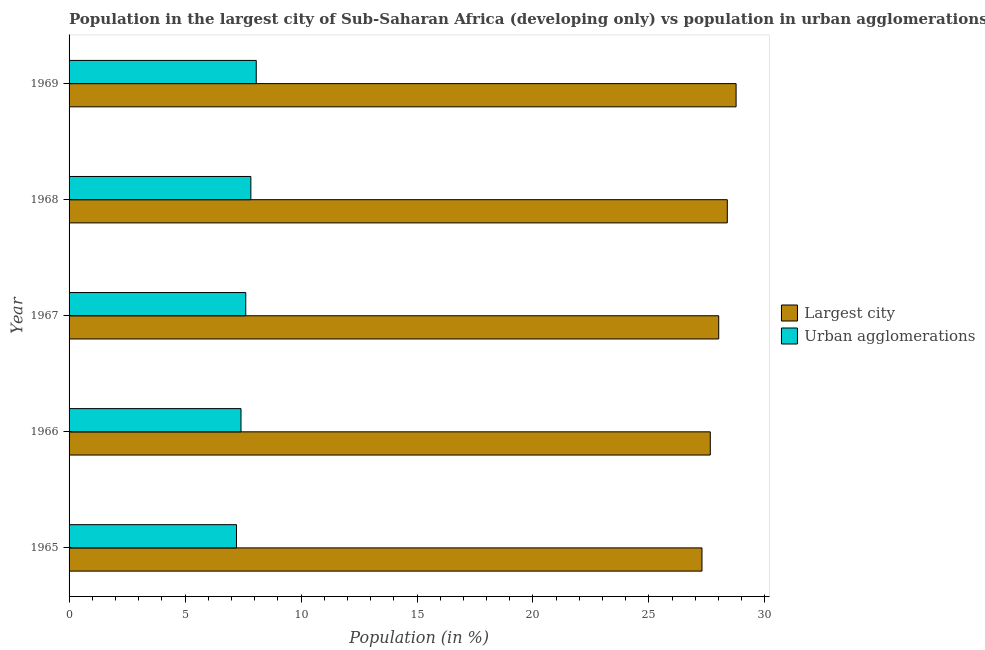How many different coloured bars are there?
Keep it short and to the point. 2. Are the number of bars per tick equal to the number of legend labels?
Provide a short and direct response. Yes. Are the number of bars on each tick of the Y-axis equal?
Your answer should be compact. Yes. What is the label of the 1st group of bars from the top?
Keep it short and to the point. 1969. What is the population in urban agglomerations in 1969?
Your answer should be compact. 8.07. Across all years, what is the maximum population in urban agglomerations?
Ensure brevity in your answer.  8.07. Across all years, what is the minimum population in urban agglomerations?
Ensure brevity in your answer.  7.22. In which year was the population in the largest city maximum?
Your answer should be very brief. 1969. In which year was the population in urban agglomerations minimum?
Give a very brief answer. 1965. What is the total population in urban agglomerations in the graph?
Provide a succinct answer. 38.16. What is the difference between the population in the largest city in 1967 and that in 1968?
Your answer should be compact. -0.37. What is the difference between the population in the largest city in 1967 and the population in urban agglomerations in 1969?
Offer a terse response. 19.94. What is the average population in urban agglomerations per year?
Provide a succinct answer. 7.63. In the year 1969, what is the difference between the population in the largest city and population in urban agglomerations?
Provide a succinct answer. 20.69. In how many years, is the population in urban agglomerations greater than 16 %?
Your answer should be compact. 0. What is the ratio of the population in urban agglomerations in 1968 to that in 1969?
Provide a short and direct response. 0.97. Is the difference between the population in urban agglomerations in 1966 and 1968 greater than the difference between the population in the largest city in 1966 and 1968?
Provide a succinct answer. Yes. What is the difference between the highest and the second highest population in the largest city?
Give a very brief answer. 0.38. What is the difference between the highest and the lowest population in urban agglomerations?
Offer a very short reply. 0.85. What does the 2nd bar from the top in 1965 represents?
Ensure brevity in your answer.  Largest city. What does the 1st bar from the bottom in 1967 represents?
Provide a short and direct response. Largest city. How many years are there in the graph?
Provide a short and direct response. 5. Where does the legend appear in the graph?
Your answer should be compact. Center right. How many legend labels are there?
Your answer should be very brief. 2. How are the legend labels stacked?
Ensure brevity in your answer.  Vertical. What is the title of the graph?
Keep it short and to the point. Population in the largest city of Sub-Saharan Africa (developing only) vs population in urban agglomerations. What is the label or title of the X-axis?
Provide a succinct answer. Population (in %). What is the Population (in %) of Largest city in 1965?
Provide a short and direct response. 27.29. What is the Population (in %) in Urban agglomerations in 1965?
Give a very brief answer. 7.22. What is the Population (in %) in Largest city in 1966?
Offer a very short reply. 27.64. What is the Population (in %) of Urban agglomerations in 1966?
Your answer should be compact. 7.41. What is the Population (in %) of Largest city in 1967?
Offer a very short reply. 28.01. What is the Population (in %) in Urban agglomerations in 1967?
Keep it short and to the point. 7.62. What is the Population (in %) of Largest city in 1968?
Provide a short and direct response. 28.38. What is the Population (in %) of Urban agglomerations in 1968?
Offer a terse response. 7.84. What is the Population (in %) of Largest city in 1969?
Provide a succinct answer. 28.76. What is the Population (in %) of Urban agglomerations in 1969?
Ensure brevity in your answer.  8.07. Across all years, what is the maximum Population (in %) in Largest city?
Make the answer very short. 28.76. Across all years, what is the maximum Population (in %) in Urban agglomerations?
Your answer should be very brief. 8.07. Across all years, what is the minimum Population (in %) of Largest city?
Your answer should be very brief. 27.29. Across all years, what is the minimum Population (in %) of Urban agglomerations?
Keep it short and to the point. 7.22. What is the total Population (in %) in Largest city in the graph?
Give a very brief answer. 140.07. What is the total Population (in %) of Urban agglomerations in the graph?
Your answer should be compact. 38.16. What is the difference between the Population (in %) in Largest city in 1965 and that in 1966?
Provide a succinct answer. -0.36. What is the difference between the Population (in %) in Urban agglomerations in 1965 and that in 1966?
Offer a terse response. -0.19. What is the difference between the Population (in %) in Largest city in 1965 and that in 1967?
Offer a very short reply. -0.72. What is the difference between the Population (in %) of Urban agglomerations in 1965 and that in 1967?
Give a very brief answer. -0.4. What is the difference between the Population (in %) of Largest city in 1965 and that in 1968?
Make the answer very short. -1.09. What is the difference between the Population (in %) in Urban agglomerations in 1965 and that in 1968?
Ensure brevity in your answer.  -0.62. What is the difference between the Population (in %) in Largest city in 1965 and that in 1969?
Offer a terse response. -1.47. What is the difference between the Population (in %) in Urban agglomerations in 1965 and that in 1969?
Keep it short and to the point. -0.85. What is the difference between the Population (in %) in Largest city in 1966 and that in 1967?
Your response must be concise. -0.36. What is the difference between the Population (in %) of Urban agglomerations in 1966 and that in 1967?
Provide a succinct answer. -0.21. What is the difference between the Population (in %) of Largest city in 1966 and that in 1968?
Your answer should be compact. -0.73. What is the difference between the Population (in %) of Urban agglomerations in 1966 and that in 1968?
Offer a terse response. -0.43. What is the difference between the Population (in %) in Largest city in 1966 and that in 1969?
Ensure brevity in your answer.  -1.11. What is the difference between the Population (in %) in Urban agglomerations in 1966 and that in 1969?
Your answer should be compact. -0.66. What is the difference between the Population (in %) in Largest city in 1967 and that in 1968?
Offer a terse response. -0.37. What is the difference between the Population (in %) of Urban agglomerations in 1967 and that in 1968?
Offer a terse response. -0.22. What is the difference between the Population (in %) in Largest city in 1967 and that in 1969?
Make the answer very short. -0.75. What is the difference between the Population (in %) of Urban agglomerations in 1967 and that in 1969?
Provide a short and direct response. -0.45. What is the difference between the Population (in %) of Largest city in 1968 and that in 1969?
Provide a short and direct response. -0.38. What is the difference between the Population (in %) of Urban agglomerations in 1968 and that in 1969?
Provide a short and direct response. -0.23. What is the difference between the Population (in %) of Largest city in 1965 and the Population (in %) of Urban agglomerations in 1966?
Provide a succinct answer. 19.87. What is the difference between the Population (in %) of Largest city in 1965 and the Population (in %) of Urban agglomerations in 1967?
Give a very brief answer. 19.67. What is the difference between the Population (in %) of Largest city in 1965 and the Population (in %) of Urban agglomerations in 1968?
Ensure brevity in your answer.  19.45. What is the difference between the Population (in %) of Largest city in 1965 and the Population (in %) of Urban agglomerations in 1969?
Keep it short and to the point. 19.22. What is the difference between the Population (in %) in Largest city in 1966 and the Population (in %) in Urban agglomerations in 1967?
Your response must be concise. 20.03. What is the difference between the Population (in %) in Largest city in 1966 and the Population (in %) in Urban agglomerations in 1968?
Keep it short and to the point. 19.81. What is the difference between the Population (in %) in Largest city in 1966 and the Population (in %) in Urban agglomerations in 1969?
Provide a short and direct response. 19.57. What is the difference between the Population (in %) of Largest city in 1967 and the Population (in %) of Urban agglomerations in 1968?
Your answer should be very brief. 20.17. What is the difference between the Population (in %) in Largest city in 1967 and the Population (in %) in Urban agglomerations in 1969?
Make the answer very short. 19.94. What is the difference between the Population (in %) of Largest city in 1968 and the Population (in %) of Urban agglomerations in 1969?
Provide a short and direct response. 20.31. What is the average Population (in %) of Largest city per year?
Offer a terse response. 28.01. What is the average Population (in %) of Urban agglomerations per year?
Ensure brevity in your answer.  7.63. In the year 1965, what is the difference between the Population (in %) of Largest city and Population (in %) of Urban agglomerations?
Your answer should be compact. 20.07. In the year 1966, what is the difference between the Population (in %) of Largest city and Population (in %) of Urban agglomerations?
Offer a terse response. 20.23. In the year 1967, what is the difference between the Population (in %) of Largest city and Population (in %) of Urban agglomerations?
Give a very brief answer. 20.39. In the year 1968, what is the difference between the Population (in %) of Largest city and Population (in %) of Urban agglomerations?
Make the answer very short. 20.54. In the year 1969, what is the difference between the Population (in %) of Largest city and Population (in %) of Urban agglomerations?
Give a very brief answer. 20.69. What is the ratio of the Population (in %) of Urban agglomerations in 1965 to that in 1966?
Provide a succinct answer. 0.97. What is the ratio of the Population (in %) in Largest city in 1965 to that in 1967?
Offer a terse response. 0.97. What is the ratio of the Population (in %) of Urban agglomerations in 1965 to that in 1967?
Your answer should be very brief. 0.95. What is the ratio of the Population (in %) of Largest city in 1965 to that in 1968?
Give a very brief answer. 0.96. What is the ratio of the Population (in %) of Urban agglomerations in 1965 to that in 1968?
Provide a succinct answer. 0.92. What is the ratio of the Population (in %) in Largest city in 1965 to that in 1969?
Provide a short and direct response. 0.95. What is the ratio of the Population (in %) of Urban agglomerations in 1965 to that in 1969?
Provide a succinct answer. 0.89. What is the ratio of the Population (in %) in Largest city in 1966 to that in 1967?
Your answer should be compact. 0.99. What is the ratio of the Population (in %) in Urban agglomerations in 1966 to that in 1967?
Make the answer very short. 0.97. What is the ratio of the Population (in %) of Largest city in 1966 to that in 1968?
Your answer should be very brief. 0.97. What is the ratio of the Population (in %) in Urban agglomerations in 1966 to that in 1968?
Your answer should be very brief. 0.95. What is the ratio of the Population (in %) of Largest city in 1966 to that in 1969?
Provide a short and direct response. 0.96. What is the ratio of the Population (in %) of Urban agglomerations in 1966 to that in 1969?
Provide a short and direct response. 0.92. What is the ratio of the Population (in %) of Largest city in 1967 to that in 1968?
Give a very brief answer. 0.99. What is the ratio of the Population (in %) of Urban agglomerations in 1967 to that in 1968?
Give a very brief answer. 0.97. What is the ratio of the Population (in %) in Largest city in 1967 to that in 1969?
Your response must be concise. 0.97. What is the ratio of the Population (in %) in Urban agglomerations in 1967 to that in 1969?
Make the answer very short. 0.94. What is the ratio of the Population (in %) in Largest city in 1968 to that in 1969?
Provide a short and direct response. 0.99. What is the ratio of the Population (in %) in Urban agglomerations in 1968 to that in 1969?
Your answer should be compact. 0.97. What is the difference between the highest and the second highest Population (in %) of Largest city?
Make the answer very short. 0.38. What is the difference between the highest and the second highest Population (in %) in Urban agglomerations?
Offer a terse response. 0.23. What is the difference between the highest and the lowest Population (in %) of Largest city?
Provide a succinct answer. 1.47. What is the difference between the highest and the lowest Population (in %) in Urban agglomerations?
Keep it short and to the point. 0.85. 